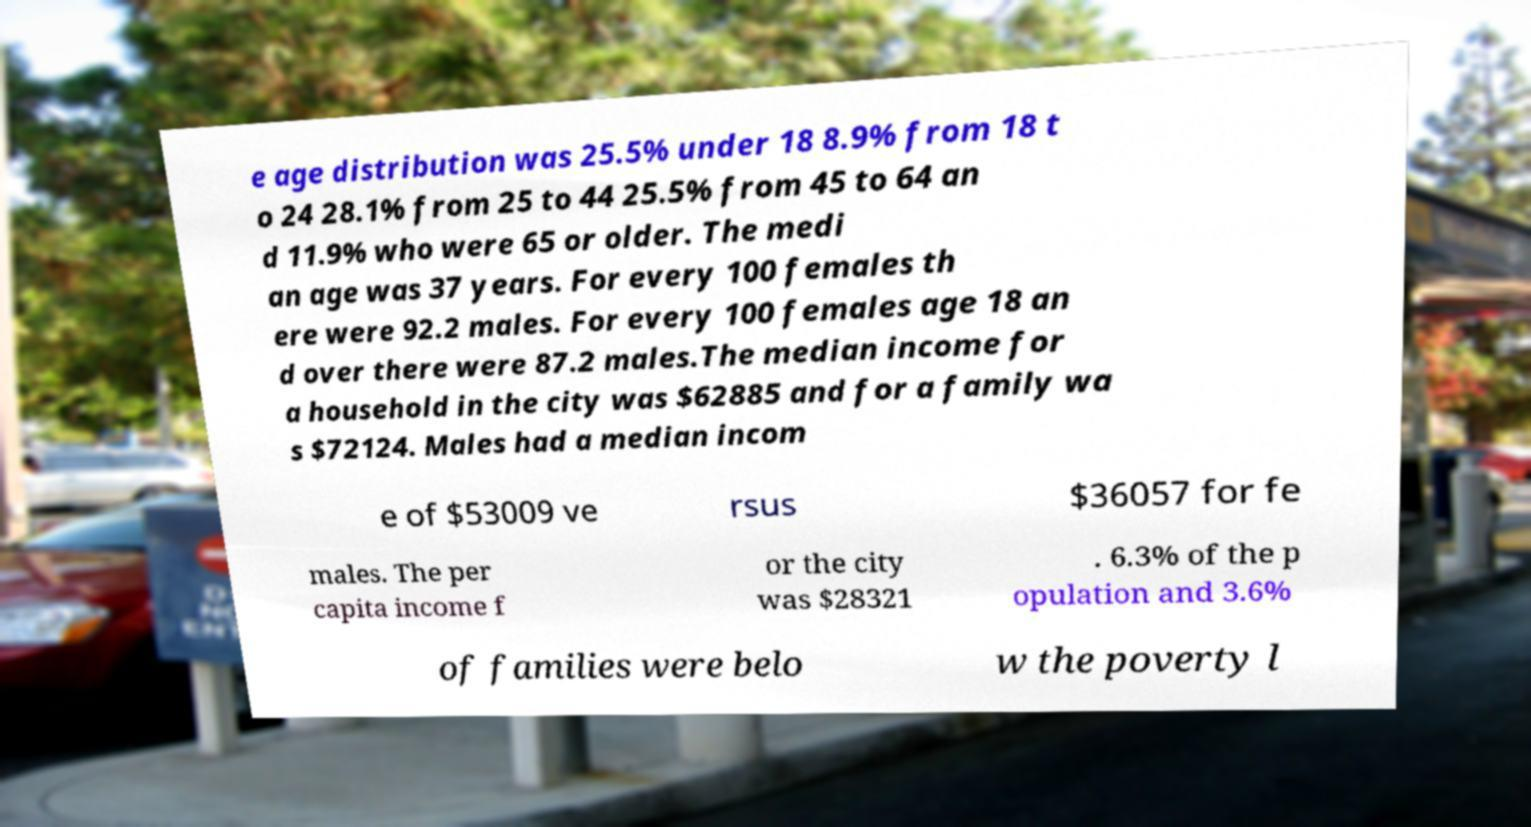There's text embedded in this image that I need extracted. Can you transcribe it verbatim? e age distribution was 25.5% under 18 8.9% from 18 t o 24 28.1% from 25 to 44 25.5% from 45 to 64 an d 11.9% who were 65 or older. The medi an age was 37 years. For every 100 females th ere were 92.2 males. For every 100 females age 18 an d over there were 87.2 males.The median income for a household in the city was $62885 and for a family wa s $72124. Males had a median incom e of $53009 ve rsus $36057 for fe males. The per capita income f or the city was $28321 . 6.3% of the p opulation and 3.6% of families were belo w the poverty l 